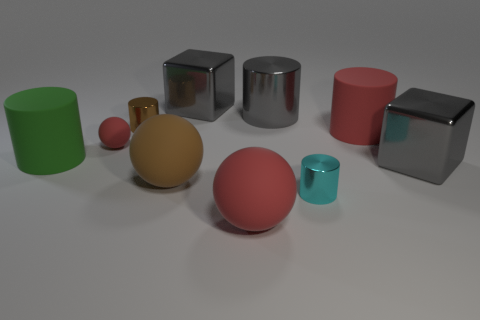There is a large gray cube in front of the green matte object; is there a big matte sphere that is in front of it?
Your answer should be compact. Yes. Is the shape of the big green rubber thing the same as the tiny rubber object?
Make the answer very short. No. There is a tiny brown object that is the same material as the gray cylinder; what is its shape?
Ensure brevity in your answer.  Cylinder. There is a green matte cylinder in front of the small brown metal cylinder; is it the same size as the brown object that is in front of the tiny rubber sphere?
Your response must be concise. Yes. Are there more metallic objects behind the small red object than gray cubes that are in front of the cyan cylinder?
Ensure brevity in your answer.  Yes. What number of other things are there of the same color as the large metallic cylinder?
Offer a very short reply. 2. Is the color of the small matte thing the same as the cylinder that is on the left side of the brown cylinder?
Make the answer very short. No. There is a small thing in front of the large brown sphere; what number of tiny shiny objects are in front of it?
Your response must be concise. 0. Is there anything else that has the same material as the green thing?
Give a very brief answer. Yes. There is a big block on the left side of the cube right of the big red rubber thing in front of the green cylinder; what is it made of?
Your answer should be very brief. Metal. 